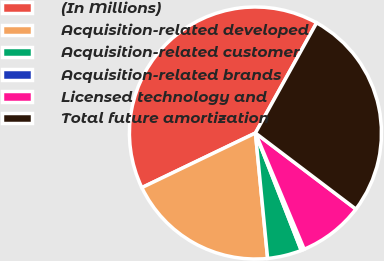Convert chart. <chart><loc_0><loc_0><loc_500><loc_500><pie_chart><fcel>(In Millions)<fcel>Acquisition-related developed<fcel>Acquisition-related customer<fcel>Acquisition-related brands<fcel>Licensed technology and<fcel>Total future amortization<nl><fcel>40.2%<fcel>19.41%<fcel>4.38%<fcel>0.4%<fcel>8.36%<fcel>27.25%<nl></chart> 